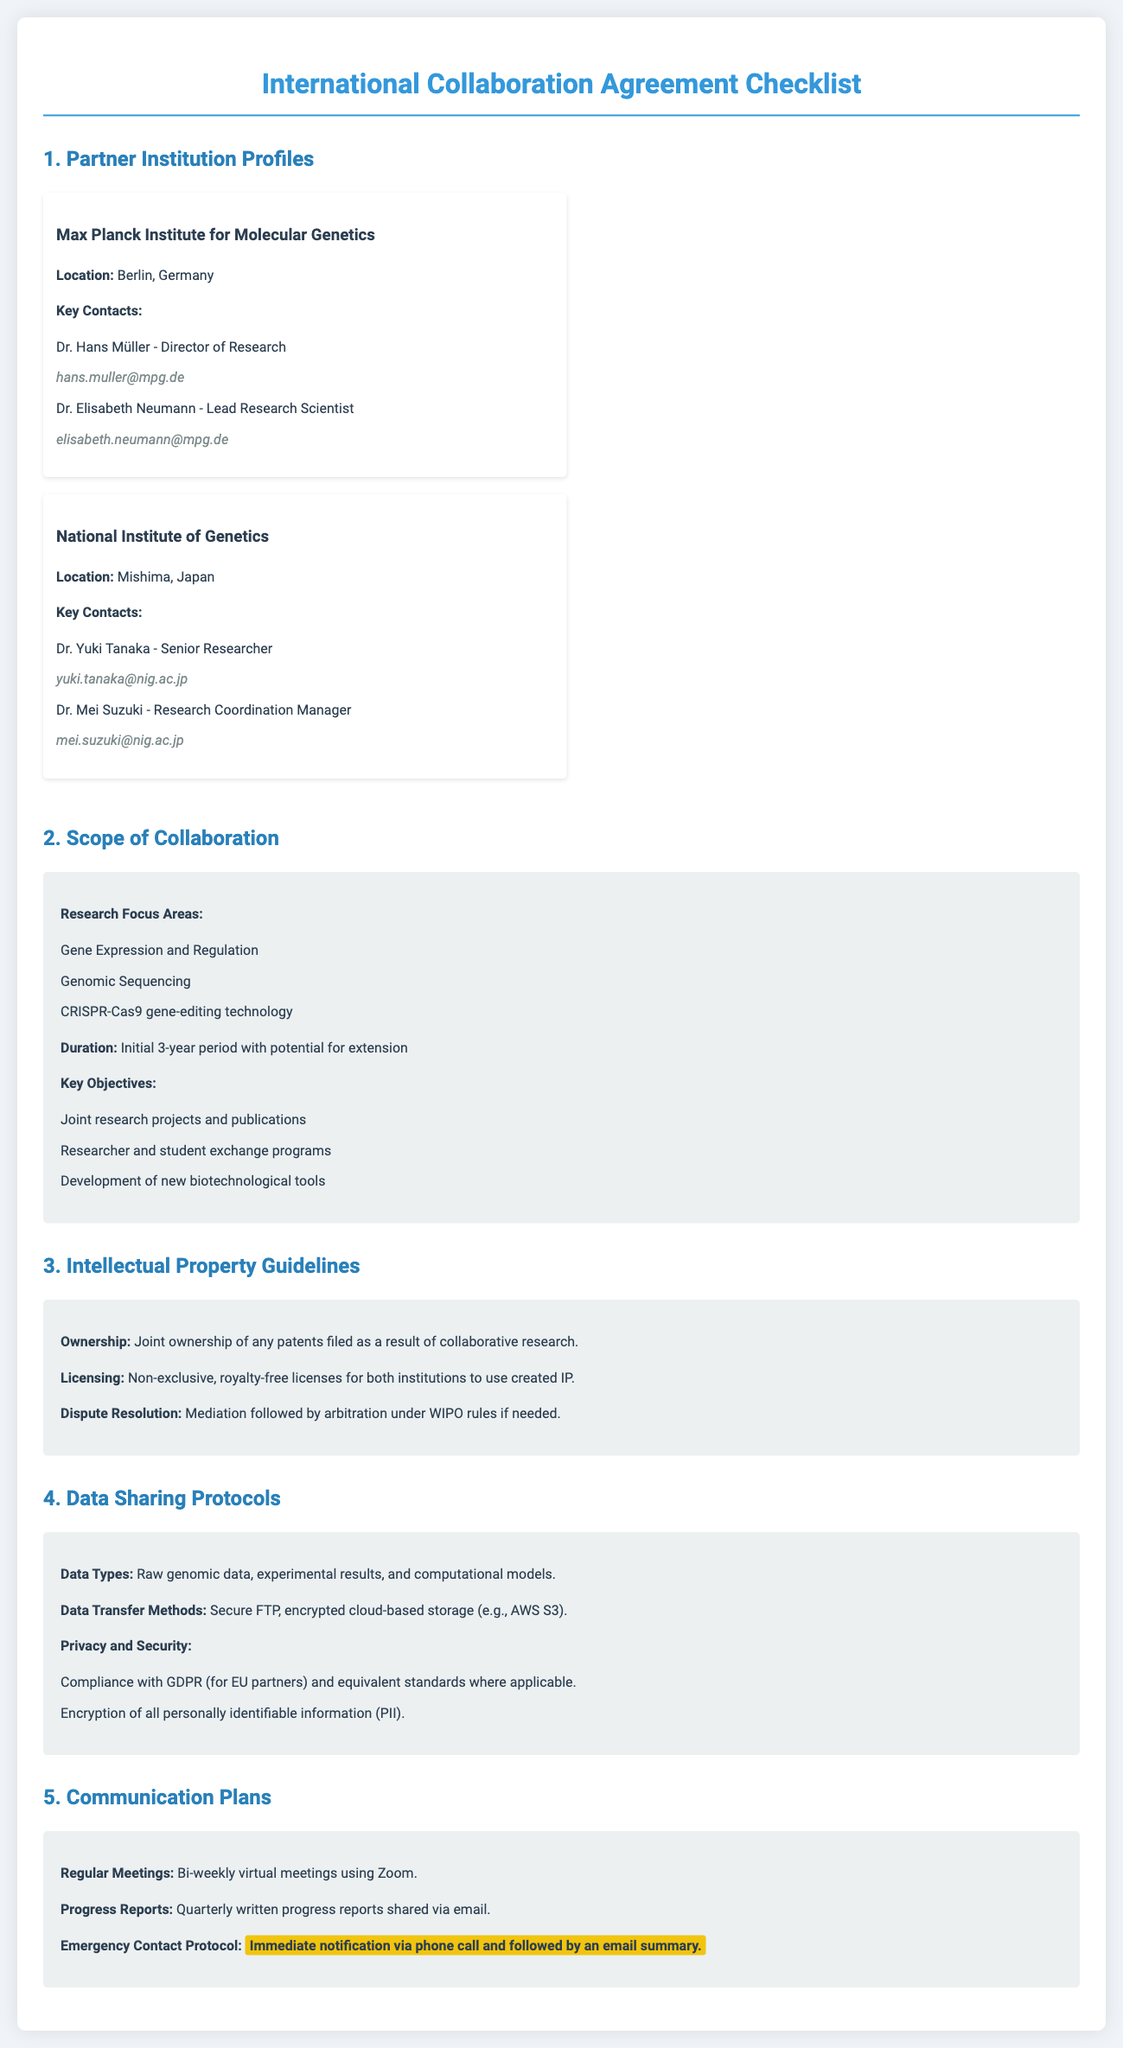What is the location of the Max Planck Institute for Molecular Genetics? The location of the Max Planck Institute for Molecular Genetics is mentioned in the Partner Institution Profiles section of the document.
Answer: Berlin, Germany Who is the Director of Research at the Max Planck Institute? The document provides names and roles of key contacts under the Partner Institution Profiles section.
Answer: Dr. Hans Müller What are the main research focus areas listed in the document? The main research focus areas can be found in the Scope of Collaboration section.
Answer: Gene Expression and Regulation, Genomic Sequencing, CRISPR-Cas9 gene-editing technology What is the duration of the collaboration? The duration of the collaboration is clearly stated in the Scope of Collaboration section.
Answer: Initial 3-year period What type of licenses are granted for intellectual property? The type of licenses for intellectual property is described under the Intellectual Property Guidelines section.
Answer: Non-exclusive, royalty-free licenses What is the method of data transfer mentioned in the document? The method of data transfer is specified in the Data Sharing Protocols section.
Answer: Secure FTP, encrypted cloud-based storage How often will progress reports be shared according to the document? The frequency of progress reports is included in the Communication Plans section.
Answer: Quarterly What does the emergency contact protocol specify? The emergency contact protocol details can be found in the Communication Plans section, outlining how to respond in emergencies.
Answer: Immediate notification via phone call and followed by an email summary 